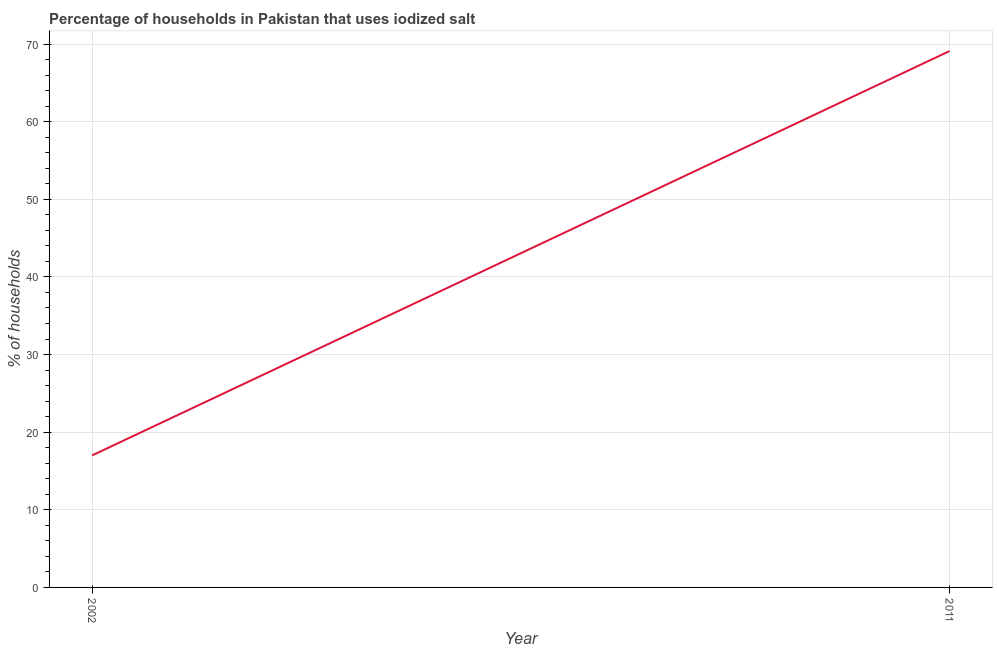What is the percentage of households where iodized salt is consumed in 2002?
Keep it short and to the point. 17. Across all years, what is the maximum percentage of households where iodized salt is consumed?
Provide a succinct answer. 69.1. Across all years, what is the minimum percentage of households where iodized salt is consumed?
Make the answer very short. 17. What is the sum of the percentage of households where iodized salt is consumed?
Keep it short and to the point. 86.1. What is the difference between the percentage of households where iodized salt is consumed in 2002 and 2011?
Provide a succinct answer. -52.1. What is the average percentage of households where iodized salt is consumed per year?
Offer a very short reply. 43.05. What is the median percentage of households where iodized salt is consumed?
Keep it short and to the point. 43.05. In how many years, is the percentage of households where iodized salt is consumed greater than 28 %?
Your answer should be compact. 1. Do a majority of the years between 2011 and 2002 (inclusive) have percentage of households where iodized salt is consumed greater than 4 %?
Make the answer very short. No. What is the ratio of the percentage of households where iodized salt is consumed in 2002 to that in 2011?
Your answer should be compact. 0.25. Is the percentage of households where iodized salt is consumed in 2002 less than that in 2011?
Your response must be concise. Yes. How many lines are there?
Offer a very short reply. 1. What is the difference between two consecutive major ticks on the Y-axis?
Provide a short and direct response. 10. Are the values on the major ticks of Y-axis written in scientific E-notation?
Offer a terse response. No. Does the graph contain grids?
Offer a very short reply. Yes. What is the title of the graph?
Your response must be concise. Percentage of households in Pakistan that uses iodized salt. What is the label or title of the Y-axis?
Offer a very short reply. % of households. What is the % of households of 2002?
Your answer should be compact. 17. What is the % of households in 2011?
Your answer should be very brief. 69.1. What is the difference between the % of households in 2002 and 2011?
Offer a very short reply. -52.1. What is the ratio of the % of households in 2002 to that in 2011?
Ensure brevity in your answer.  0.25. 